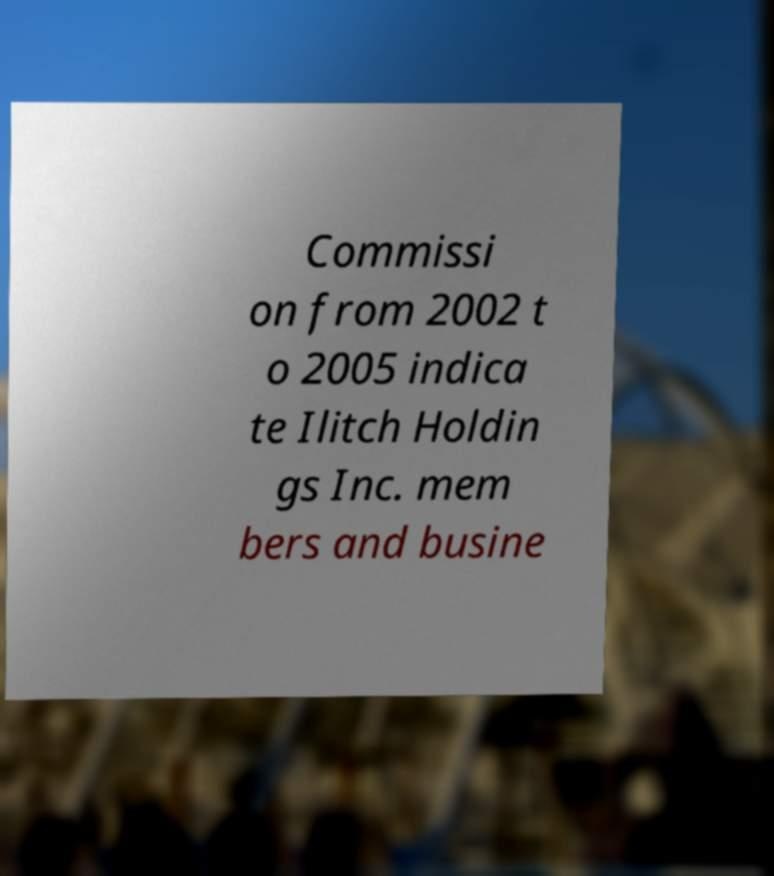Please read and relay the text visible in this image. What does it say? Commissi on from 2002 t o 2005 indica te Ilitch Holdin gs Inc. mem bers and busine 